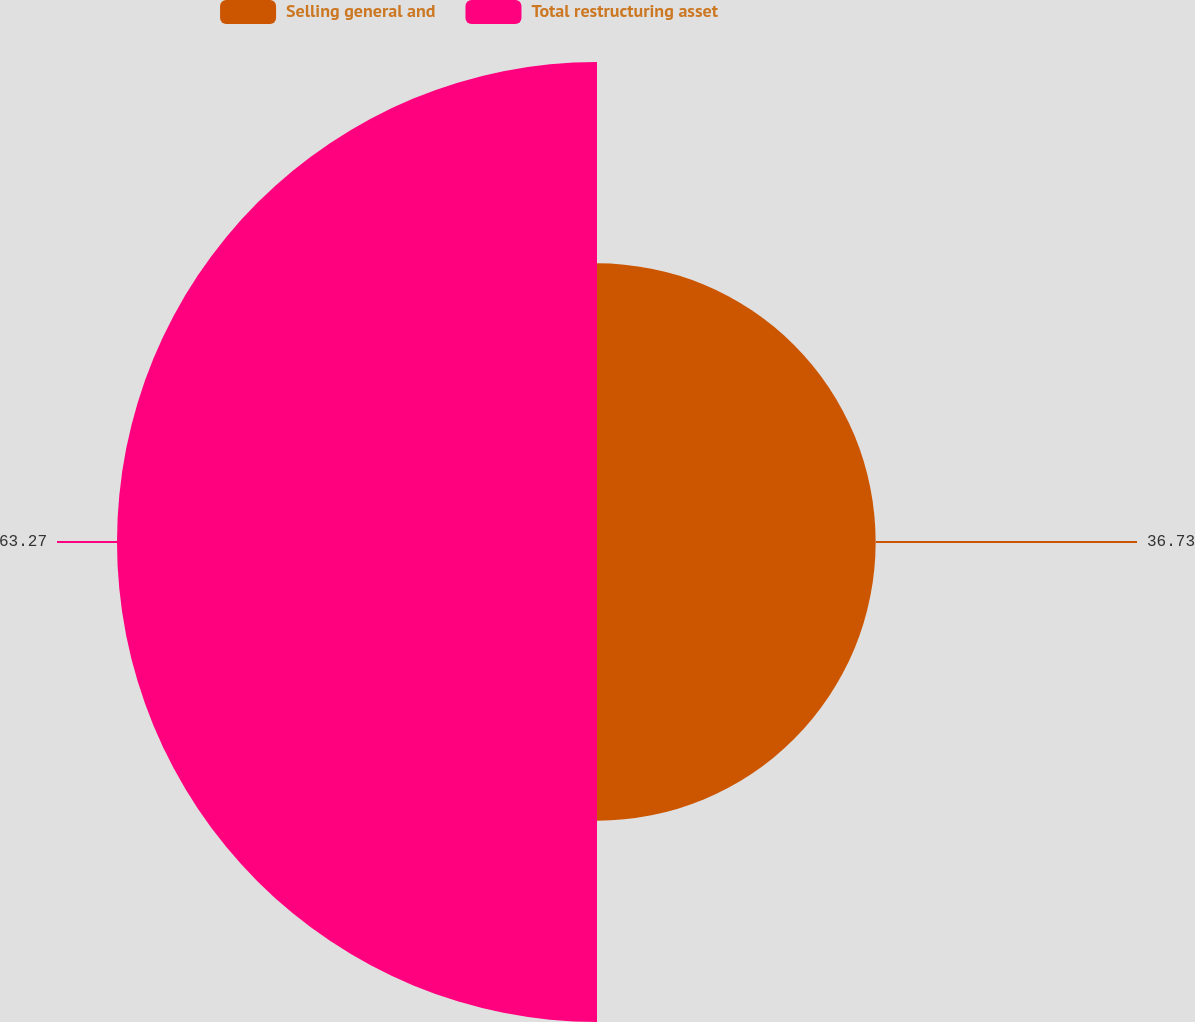Convert chart to OTSL. <chart><loc_0><loc_0><loc_500><loc_500><pie_chart><fcel>Selling general and<fcel>Total restructuring asset<nl><fcel>36.73%<fcel>63.27%<nl></chart> 